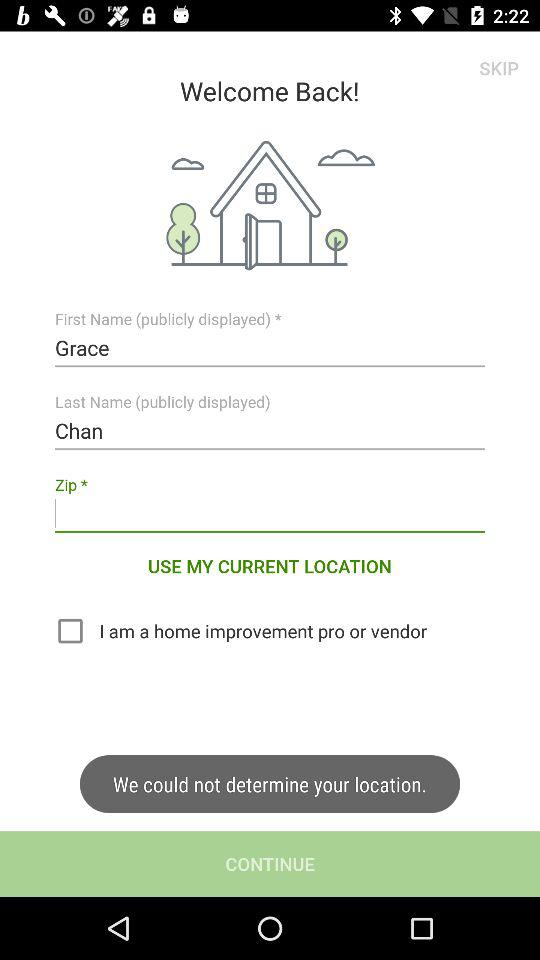How many text input fields are there for the user to fill out?
Answer the question using a single word or phrase. 3 